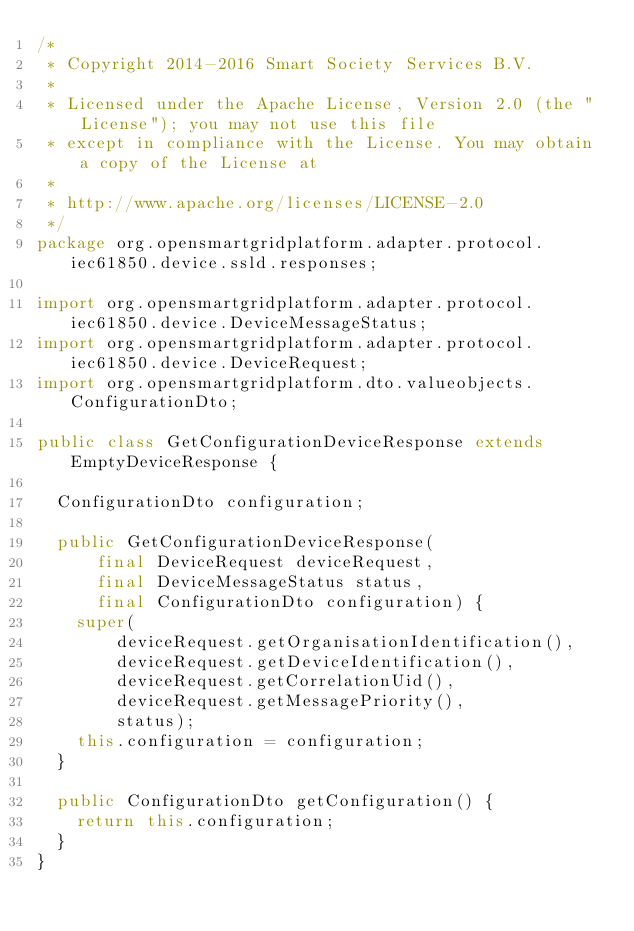<code> <loc_0><loc_0><loc_500><loc_500><_Java_>/*
 * Copyright 2014-2016 Smart Society Services B.V.
 *
 * Licensed under the Apache License, Version 2.0 (the "License"); you may not use this file
 * except in compliance with the License. You may obtain a copy of the License at
 *
 * http://www.apache.org/licenses/LICENSE-2.0
 */
package org.opensmartgridplatform.adapter.protocol.iec61850.device.ssld.responses;

import org.opensmartgridplatform.adapter.protocol.iec61850.device.DeviceMessageStatus;
import org.opensmartgridplatform.adapter.protocol.iec61850.device.DeviceRequest;
import org.opensmartgridplatform.dto.valueobjects.ConfigurationDto;

public class GetConfigurationDeviceResponse extends EmptyDeviceResponse {

  ConfigurationDto configuration;

  public GetConfigurationDeviceResponse(
      final DeviceRequest deviceRequest,
      final DeviceMessageStatus status,
      final ConfigurationDto configuration) {
    super(
        deviceRequest.getOrganisationIdentification(),
        deviceRequest.getDeviceIdentification(),
        deviceRequest.getCorrelationUid(),
        deviceRequest.getMessagePriority(),
        status);
    this.configuration = configuration;
  }

  public ConfigurationDto getConfiguration() {
    return this.configuration;
  }
}
</code> 